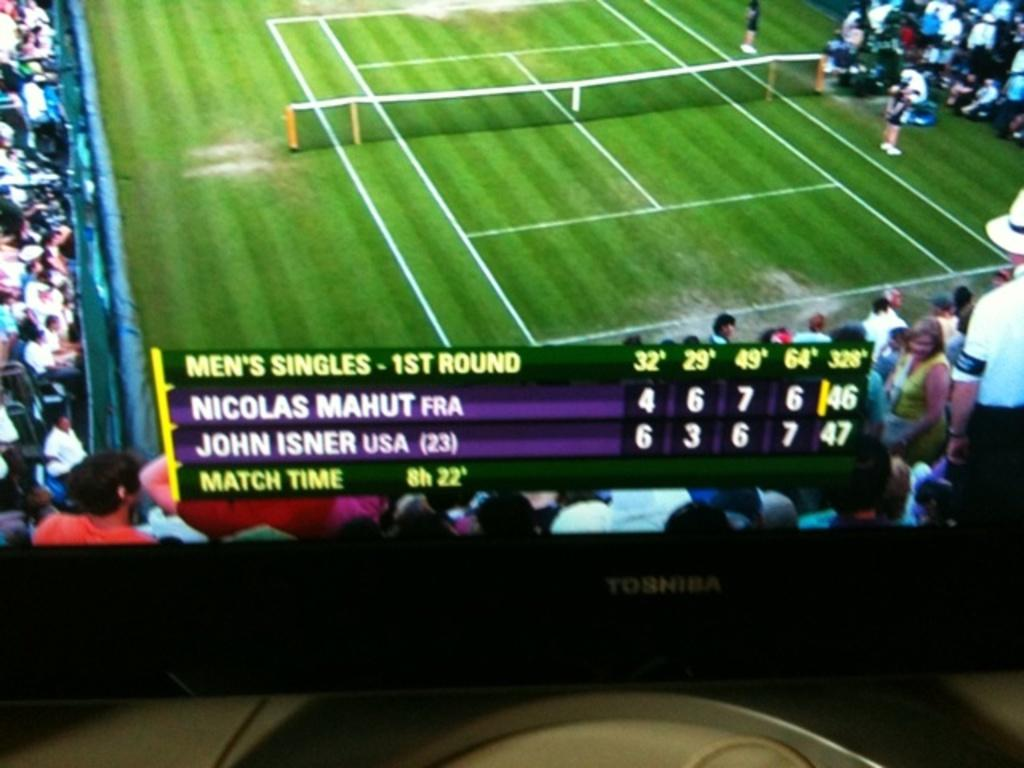<image>
Relay a brief, clear account of the picture shown. Nicolas Mahut and John Isner play in the 1st round of Mens Singles 